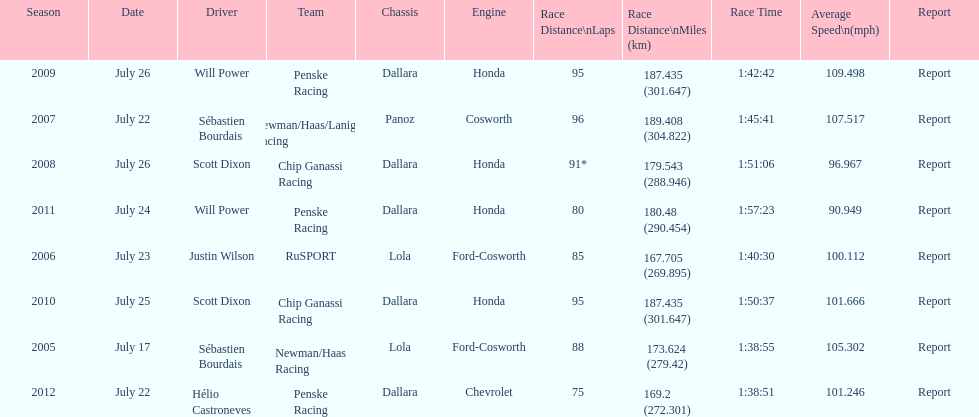Would you mind parsing the complete table? {'header': ['Season', 'Date', 'Driver', 'Team', 'Chassis', 'Engine', 'Race Distance\\nLaps', 'Race Distance\\nMiles (km)', 'Race Time', 'Average Speed\\n(mph)', 'Report'], 'rows': [['2009', 'July 26', 'Will Power', 'Penske Racing', 'Dallara', 'Honda', '95', '187.435 (301.647)', '1:42:42', '109.498', 'Report'], ['2007', 'July 22', 'Sébastien Bourdais', 'Newman/Haas/Lanigan Racing', 'Panoz', 'Cosworth', '96', '189.408 (304.822)', '1:45:41', '107.517', 'Report'], ['2008', 'July 26', 'Scott Dixon', 'Chip Ganassi Racing', 'Dallara', 'Honda', '91*', '179.543 (288.946)', '1:51:06', '96.967', 'Report'], ['2011', 'July 24', 'Will Power', 'Penske Racing', 'Dallara', 'Honda', '80', '180.48 (290.454)', '1:57:23', '90.949', 'Report'], ['2006', 'July 23', 'Justin Wilson', 'RuSPORT', 'Lola', 'Ford-Cosworth', '85', '167.705 (269.895)', '1:40:30', '100.112', 'Report'], ['2010', 'July 25', 'Scott Dixon', 'Chip Ganassi Racing', 'Dallara', 'Honda', '95', '187.435 (301.647)', '1:50:37', '101.666', 'Report'], ['2005', 'July 17', 'Sébastien Bourdais', 'Newman/Haas Racing', 'Lola', 'Ford-Cosworth', '88', '173.624 (279.42)', '1:38:55', '105.302', 'Report'], ['2012', 'July 22', 'Hélio Castroneves', 'Penske Racing', 'Dallara', 'Chevrolet', '75', '169.2 (272.301)', '1:38:51', '101.246', 'Report']]} How many total honda engines were there? 4. 